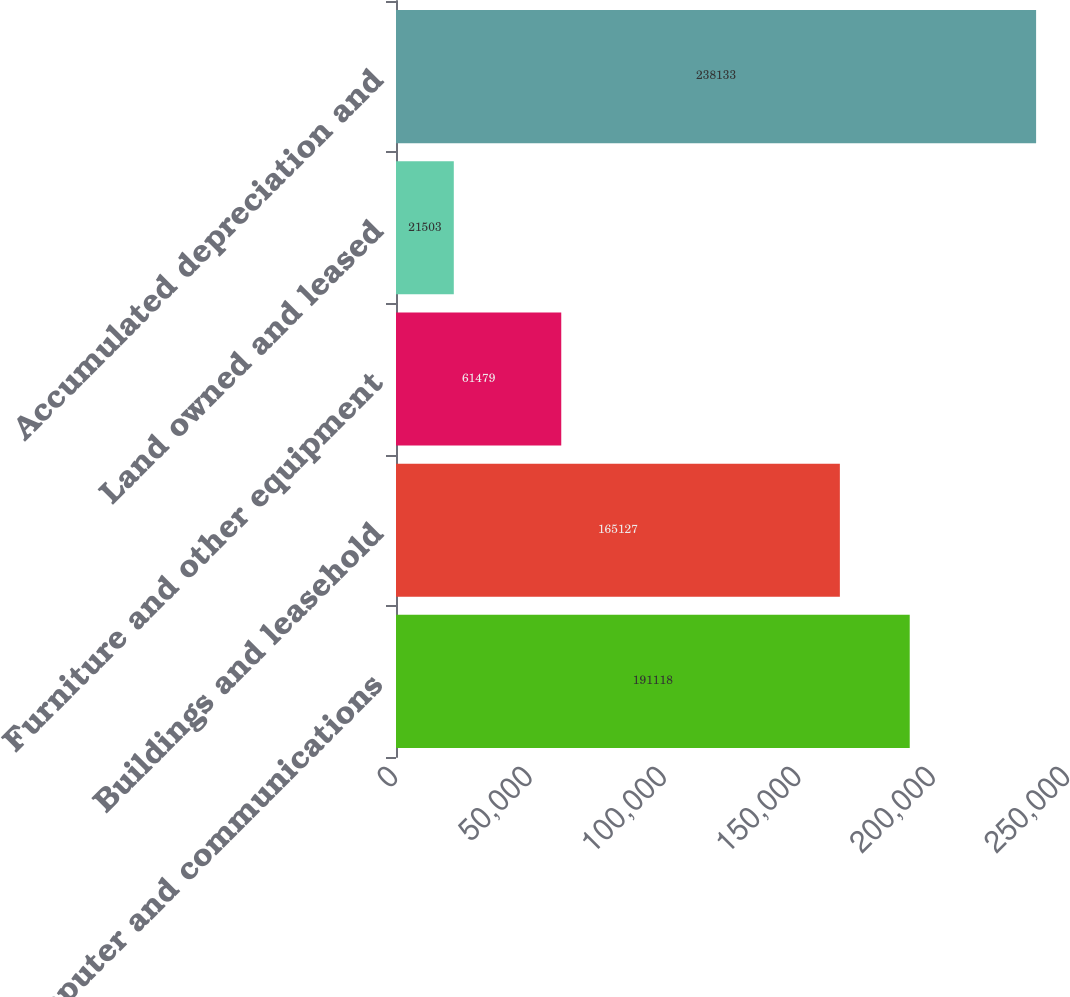<chart> <loc_0><loc_0><loc_500><loc_500><bar_chart><fcel>Computer and communications<fcel>Buildings and leasehold<fcel>Furniture and other equipment<fcel>Land owned and leased<fcel>Accumulated depreciation and<nl><fcel>191118<fcel>165127<fcel>61479<fcel>21503<fcel>238133<nl></chart> 